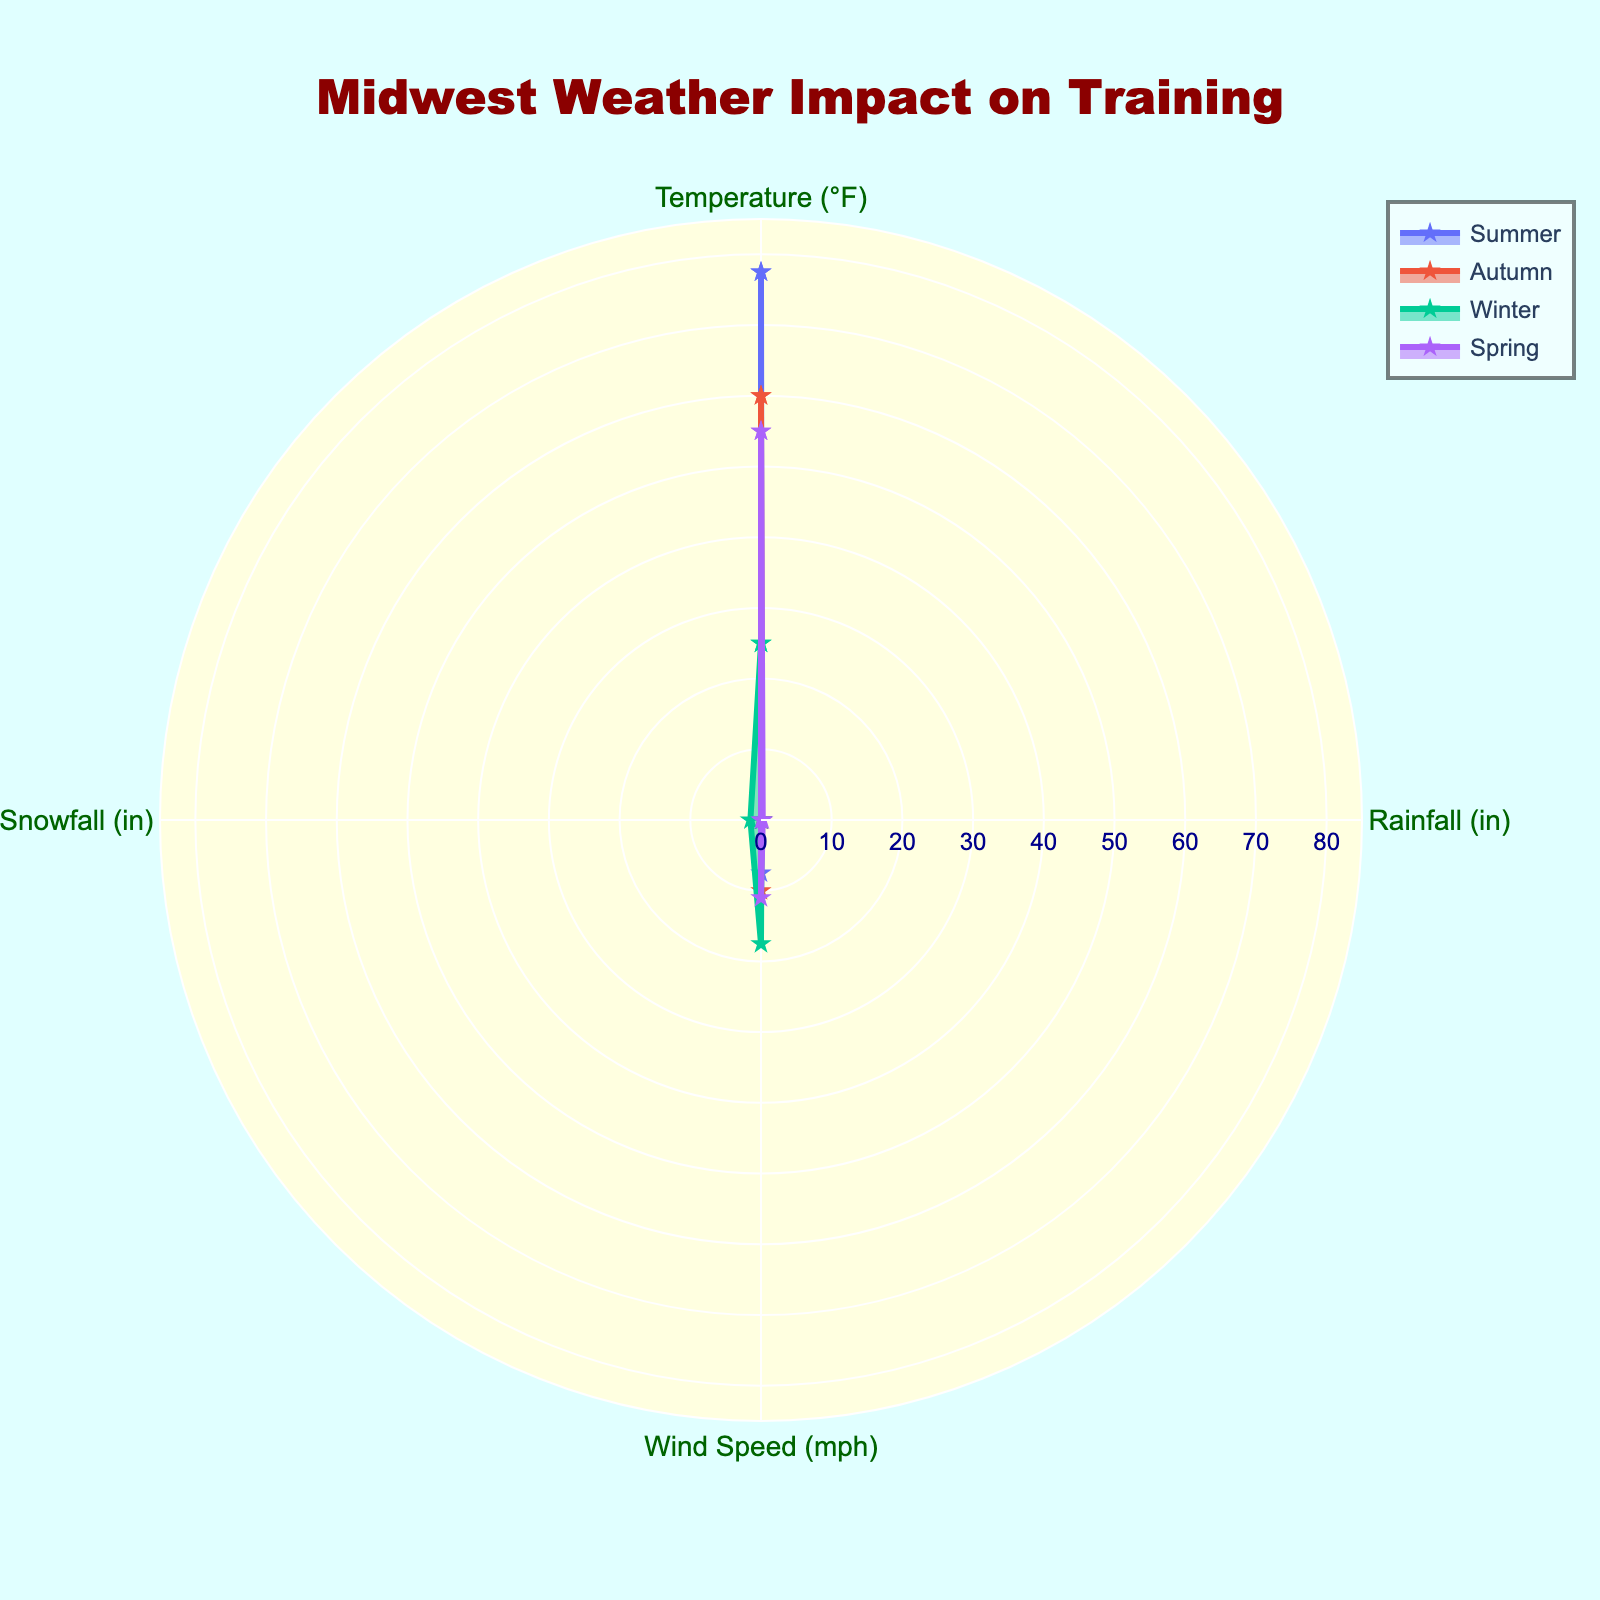Which season has the highest average temperature? Comparing the radar chart values for 'Temperature (°F)', Summer has the highest average temperature as its polygon extends further out in the temperature axis compared to other seasons.
Answer: Summer How much more rainfall does Spring experience compared to Summer? On the radar chart, the value for 'Rainfall (in)' can be compared directly. Spring has higher values depicted on the rainfall axis than Summer. The difference can be calculated from the chart values.
Answer: 0.25 inches Which season has the highest wind speed? By observing the radar chart's 'Wind Speed (mph)' axis, Winter shows the farthest extension, indicating it has the highest wind speed.
Answer: Winter What is the range of snowfall values among the seasons? Snowfall values on the radar chart start from 0 (Summer, Autumn, and Spring) and go up to Winter's value, which extends furthest on the 'Snowfall (in)' axis. Adding the visible min and max values, the range is 0 to 2 inches.
Answer: 2 inches Which two seasons have the closest average temperature? By comparing the 'Temperature (°F)' values from the radar chart, Autumn and Spring have the polygons that are closer in the temperature axis.
Answer: Autumn and Spring During which season does training experience the least rainfall? The 'Rainfall (in)' axis of the radar chart for Summer is the shortest, indicating the least amount of rainfall.
Answer: Summer How do the wind speeds of Spring and Autumn compare? The radar chart shows both axes of 'Wind Speed (mph)' for Spring and Autumn. They are compared by observing the extent of their respective polygons. Spring and Autumn have similar wind speed values, but Autumn's wind speed is slightly higher.
Answer: Autumn is higher What training season has no snowfall? By examining the 'Snowfall (in)' values on the radar chart, Summer, Autumn, and Spring polygons do not extend along the snowfall axis, indicating no snowfall.
Answer: Summer, Autumn, Spring What is the total of all average snowfall values for each season? From the radar chart, the seasons' respective snowfall values (Summer: 0, Autumn: 0, Winter: 2, Spring: 0) are summed up.
Answer: 2 inches Which season shows the most variability in weather conditions? Observing the radar chart, Winter has the largest spread across all weather condition axes (temperature low, high rain, high wind, and snowfall).
Answer: Winter 